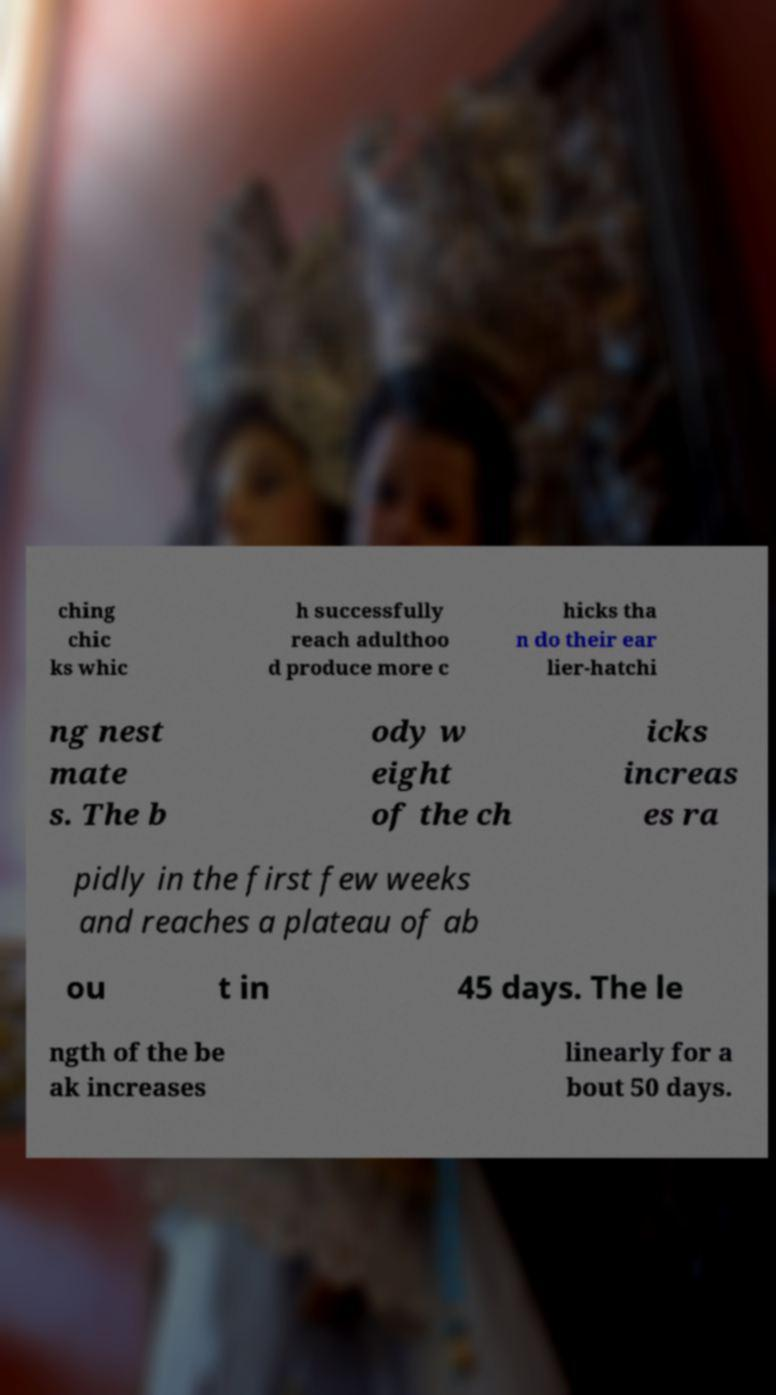Please identify and transcribe the text found in this image. ching chic ks whic h successfully reach adulthoo d produce more c hicks tha n do their ear lier-hatchi ng nest mate s. The b ody w eight of the ch icks increas es ra pidly in the first few weeks and reaches a plateau of ab ou t in 45 days. The le ngth of the be ak increases linearly for a bout 50 days. 